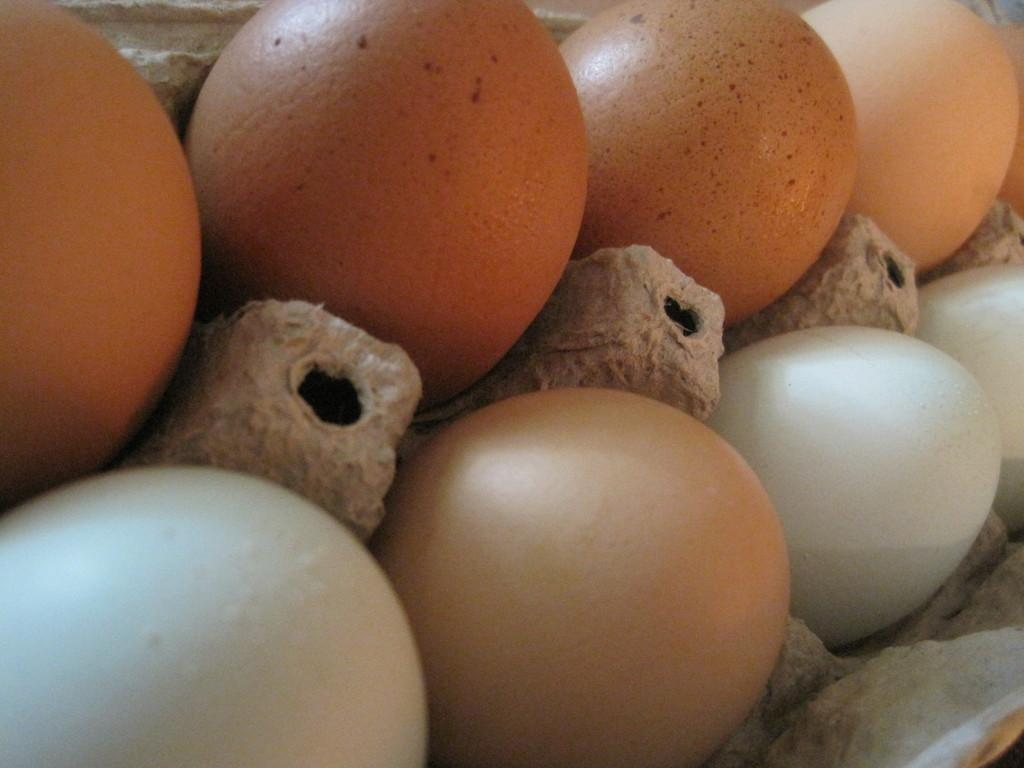What type of food item is present in the image? There are eggs in the image. What does the hope smell like in the image? There is no mention of hope or any scent in the image; it only contains eggs. 